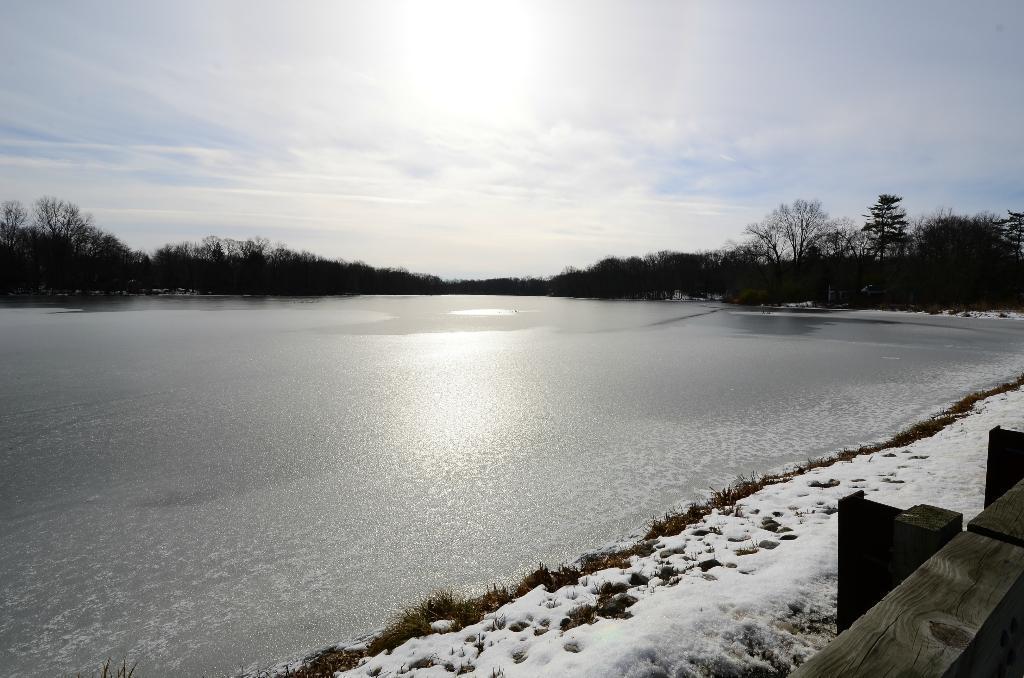Could you give a brief overview of what you see in this image? In the image there is a water surface and in front of that the land is covered with snow and in the background there are many trees. 